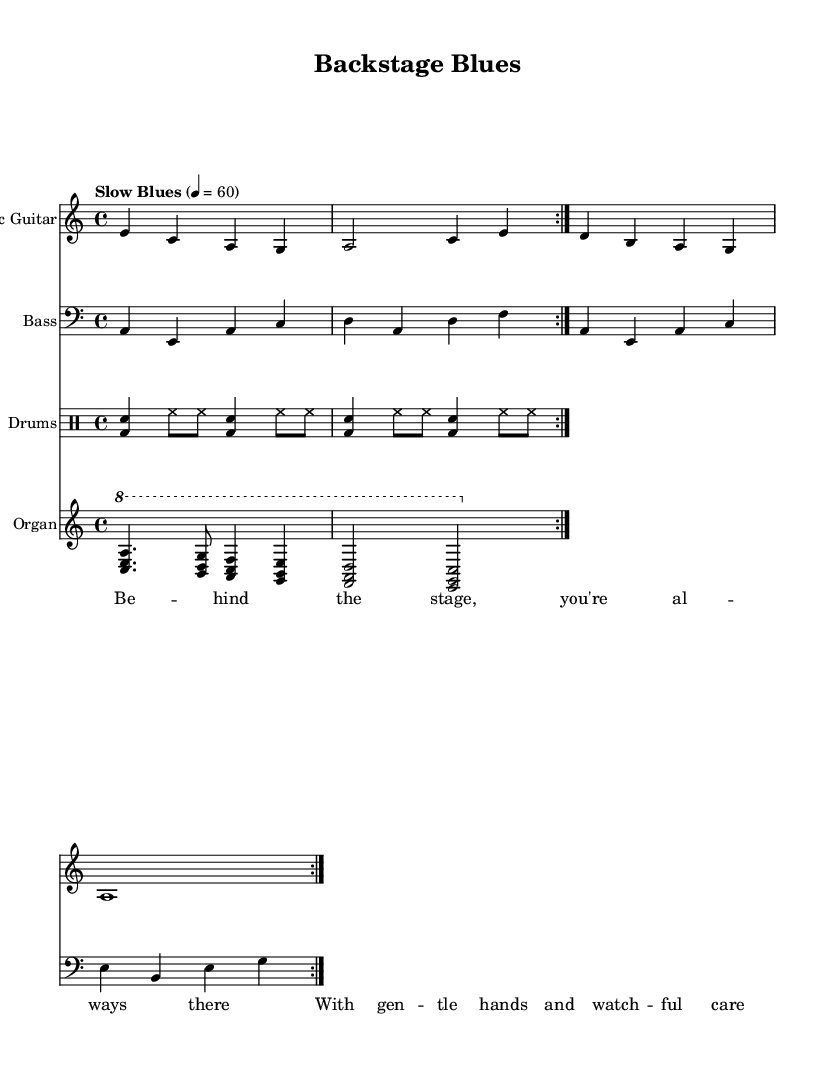What is the key signature of this music? The key signature indicates that the piece is in A minor, which has no sharps or flats. This can be confirmed by checking the music staff where the A minor key is indicated.
Answer: A minor What is the time signature of this piece? The time signature is 4/4, which is typically used in blues music. This is evident in the notation where the 4 is positioned above and below the 4 in the measures.
Answer: 4/4 What is the tempo of the song? The tempo markings specify "Slow Blues" at a speed of 60 beats per minute, which is written next to the melody in the score. This indicates the intended pace of the music.
Answer: Slow Blues 4 = 60 How many measures does the electric guitar part repeat? The electric guitar part repeats for a total of 2 measures, as indicated by the 'repeat volta' marking in the music, which signifies the repeats for that section.
Answer: 2 measures What instruments are included in the arrangement? The arrangement consists of an electric guitar, bass, drums, and organ. Each instrument is clearly labeled at the beginning of its respective staff, denoting the instruments used in the performance.
Answer: Electric guitar, bass, drums, organ What emotion does the lyrical content convey? The lyrics express a sense of support and reassurance, emphasizing the bond between the artist and their support team. This is inferred from the lyrics "Behind the stage, you're always there, With gentle hands and watchful care."
Answer: Support and reassurance 